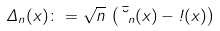Convert formula to latex. <formula><loc_0><loc_0><loc_500><loc_500>\Delta _ { n } ( x ) \colon = \sqrt { n } \, \left ( \bar { \lambda } _ { n } ( x ) - \omega ( x ) \right )</formula> 